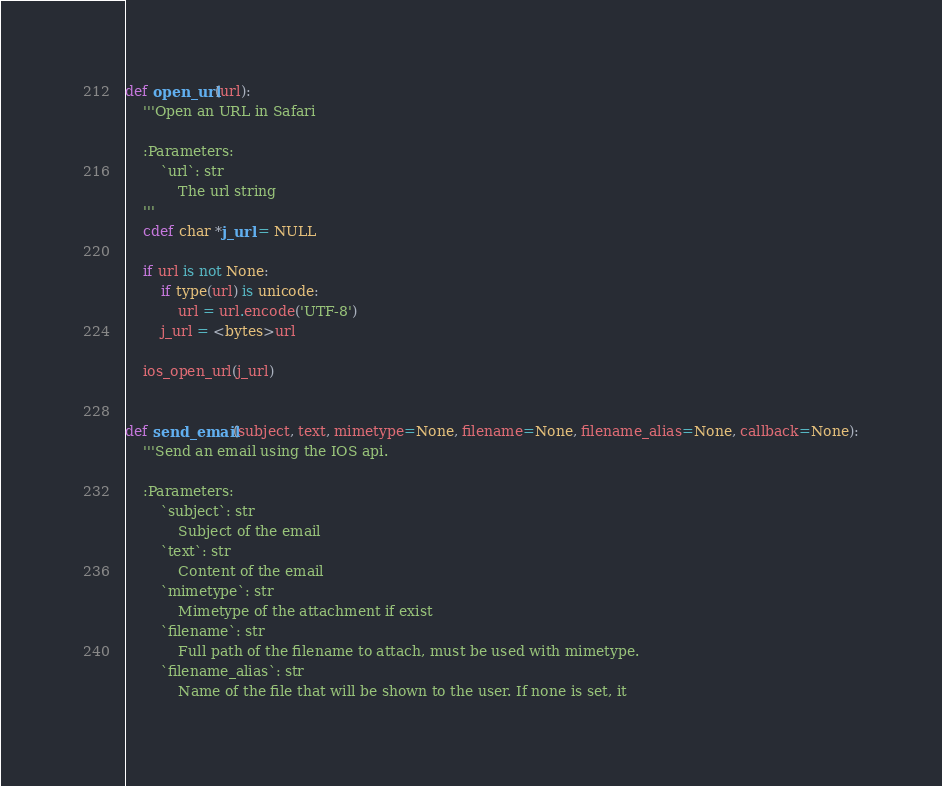<code> <loc_0><loc_0><loc_500><loc_500><_Cython_>def open_url(url):
    '''Open an URL in Safari

    :Parameters:
        `url`: str
            The url string
    '''
    cdef char *j_url = NULL

    if url is not None:
        if type(url) is unicode:
            url = url.encode('UTF-8')
        j_url = <bytes>url

    ios_open_url(j_url)


def send_email(subject, text, mimetype=None, filename=None, filename_alias=None, callback=None):
    '''Send an email using the IOS api.

    :Parameters:
        `subject`: str
            Subject of the email
        `text`: str
            Content of the email
        `mimetype`: str
            Mimetype of the attachment if exist
        `filename`: str
            Full path of the filename to attach, must be used with mimetype.
        `filename_alias`: str
            Name of the file that will be shown to the user. If none is set, it</code> 